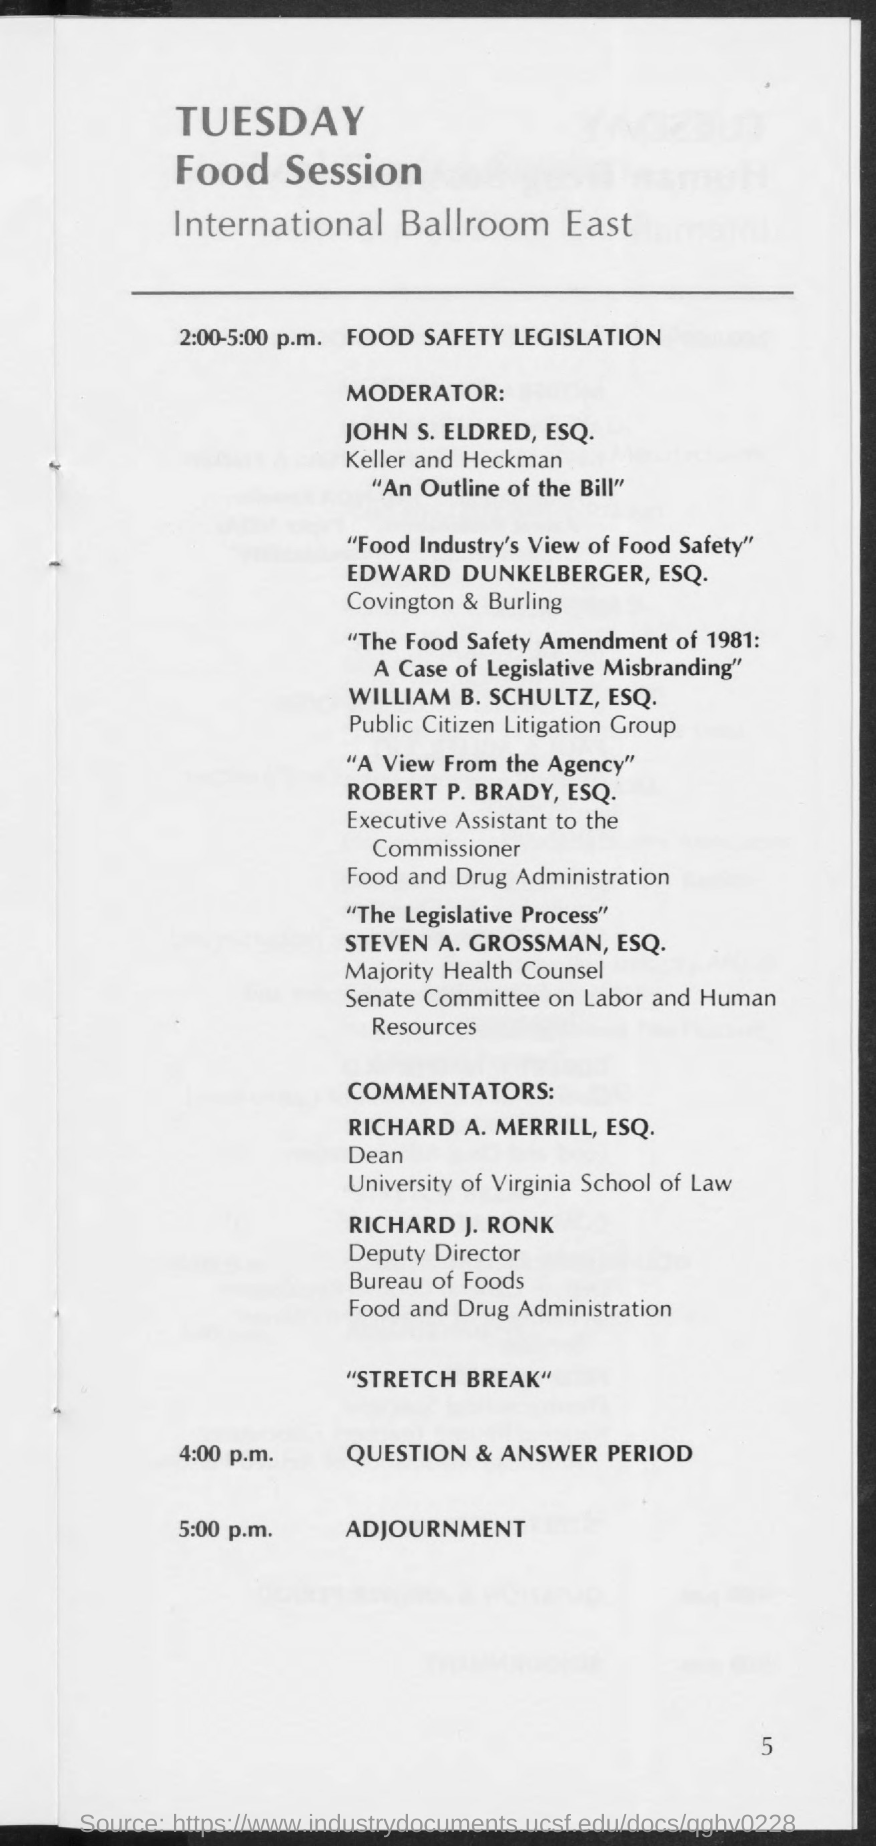Who is the moderator for the Food Safety Legislation?
Offer a very short reply. JOHN S. ELDRED, ESQ. Who is presenting the session on "Food Industry's View of Food Safety"?
Give a very brief answer. EDWARD DUNKELBERGER, ESQ. What is the designation of ROBERT P. BRADY, ESQ.?
Provide a short and direct response. Executive Assistant to the Commissioner. Which session is carried out by STEVEN A. GROSSMAN, ESQ.?
Give a very brief answer. "The Legislative Process". Who is the Dean, University of Virginia Shool of Law?
Provide a short and direct response. RICHARD A. MERRILL. What time is the Question and answer session held?
Offer a very short reply. 4:00 p.m. When are the Food Sessions adjourned?
Provide a short and direct response. 5:00 p.m. 